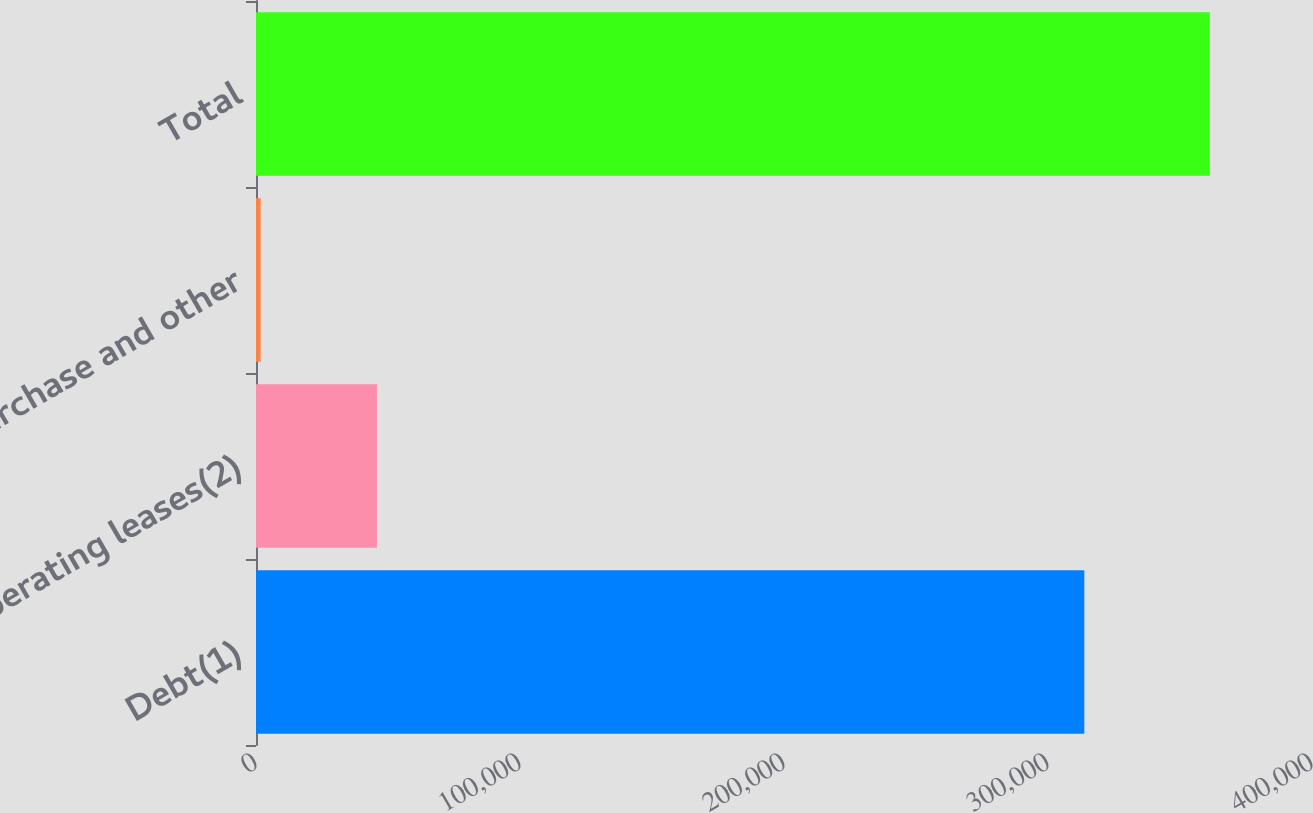Convert chart to OTSL. <chart><loc_0><loc_0><loc_500><loc_500><bar_chart><fcel>Debt(1)<fcel>Operating leases(2)<fcel>Purchase and other<fcel>Total<nl><fcel>313760<fcel>45791<fcel>1753<fcel>361304<nl></chart> 